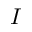Convert formula to latex. <formula><loc_0><loc_0><loc_500><loc_500>I</formula> 